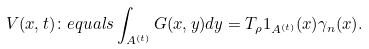<formula> <loc_0><loc_0><loc_500><loc_500>V ( x , t ) \colon e q u a l s \int _ { A ^ { ( t ) } } G ( x , y ) d y = T _ { \rho } 1 _ { A ^ { ( t ) } } ( x ) \gamma _ { n } ( x ) .</formula> 